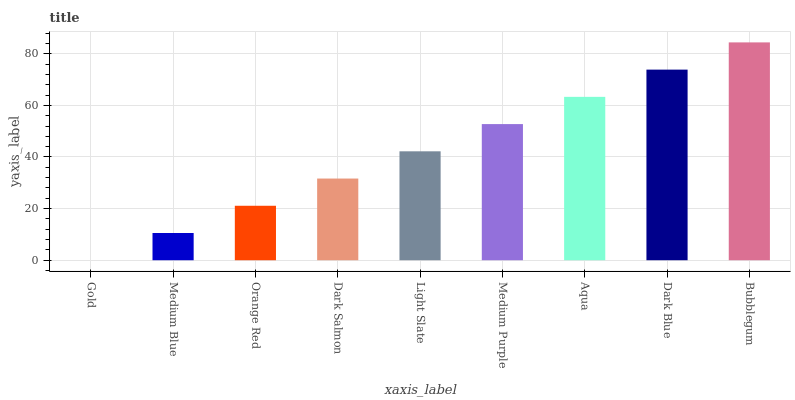Is Gold the minimum?
Answer yes or no. Yes. Is Bubblegum the maximum?
Answer yes or no. Yes. Is Medium Blue the minimum?
Answer yes or no. No. Is Medium Blue the maximum?
Answer yes or no. No. Is Medium Blue greater than Gold?
Answer yes or no. Yes. Is Gold less than Medium Blue?
Answer yes or no. Yes. Is Gold greater than Medium Blue?
Answer yes or no. No. Is Medium Blue less than Gold?
Answer yes or no. No. Is Light Slate the high median?
Answer yes or no. Yes. Is Light Slate the low median?
Answer yes or no. Yes. Is Dark Blue the high median?
Answer yes or no. No. Is Dark Blue the low median?
Answer yes or no. No. 